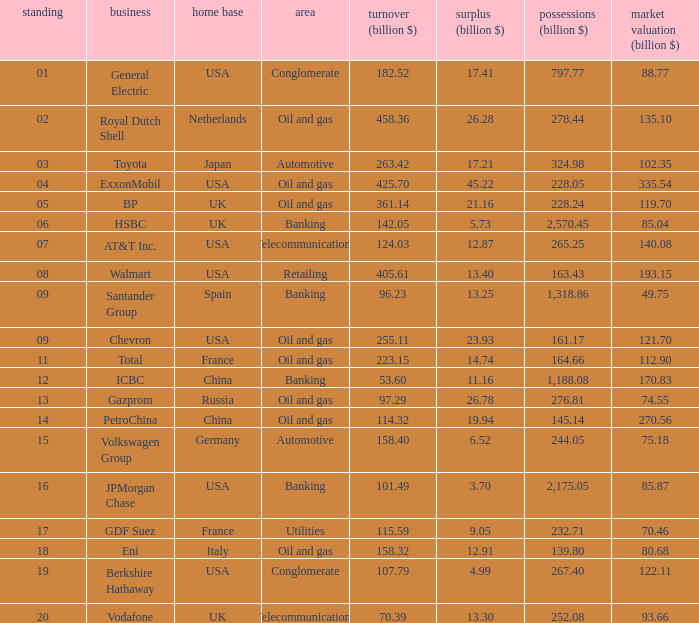Would you be able to parse every entry in this table? {'header': ['standing', 'business', 'home base', 'area', 'turnover (billion $)', 'surplus (billion $)', 'possessions (billion $)', 'market valuation (billion $)'], 'rows': [['01', 'General Electric', 'USA', 'Conglomerate', '182.52', '17.41', '797.77', '88.77'], ['02', 'Royal Dutch Shell', 'Netherlands', 'Oil and gas', '458.36', '26.28', '278.44', '135.10'], ['03', 'Toyota', 'Japan', 'Automotive', '263.42', '17.21', '324.98', '102.35'], ['04', 'ExxonMobil', 'USA', 'Oil and gas', '425.70', '45.22', '228.05', '335.54'], ['05', 'BP', 'UK', 'Oil and gas', '361.14', '21.16', '228.24', '119.70'], ['06', 'HSBC', 'UK', 'Banking', '142.05', '5.73', '2,570.45', '85.04'], ['07', 'AT&T Inc.', 'USA', 'Telecommunications', '124.03', '12.87', '265.25', '140.08'], ['08', 'Walmart', 'USA', 'Retailing', '405.61', '13.40', '163.43', '193.15'], ['09', 'Santander Group', 'Spain', 'Banking', '96.23', '13.25', '1,318.86', '49.75'], ['09', 'Chevron', 'USA', 'Oil and gas', '255.11', '23.93', '161.17', '121.70'], ['11', 'Total', 'France', 'Oil and gas', '223.15', '14.74', '164.66', '112.90'], ['12', 'ICBC', 'China', 'Banking', '53.60', '11.16', '1,188.08', '170.83'], ['13', 'Gazprom', 'Russia', 'Oil and gas', '97.29', '26.78', '276.81', '74.55'], ['14', 'PetroChina', 'China', 'Oil and gas', '114.32', '19.94', '145.14', '270.56'], ['15', 'Volkswagen Group', 'Germany', 'Automotive', '158.40', '6.52', '244.05', '75.18'], ['16', 'JPMorgan Chase', 'USA', 'Banking', '101.49', '3.70', '2,175.05', '85.87'], ['17', 'GDF Suez', 'France', 'Utilities', '115.59', '9.05', '232.71', '70.46'], ['18', 'Eni', 'Italy', 'Oil and gas', '158.32', '12.91', '139.80', '80.68'], ['19', 'Berkshire Hathaway', 'USA', 'Conglomerate', '107.79', '4.99', '267.40', '122.11'], ['20', 'Vodafone', 'UK', 'Telecommunications', '70.39', '13.30', '252.08', '93.66']]} Name the lowest Profits (billion $) which has a Sales (billion $) of 425.7, and a Rank larger than 4? None. 